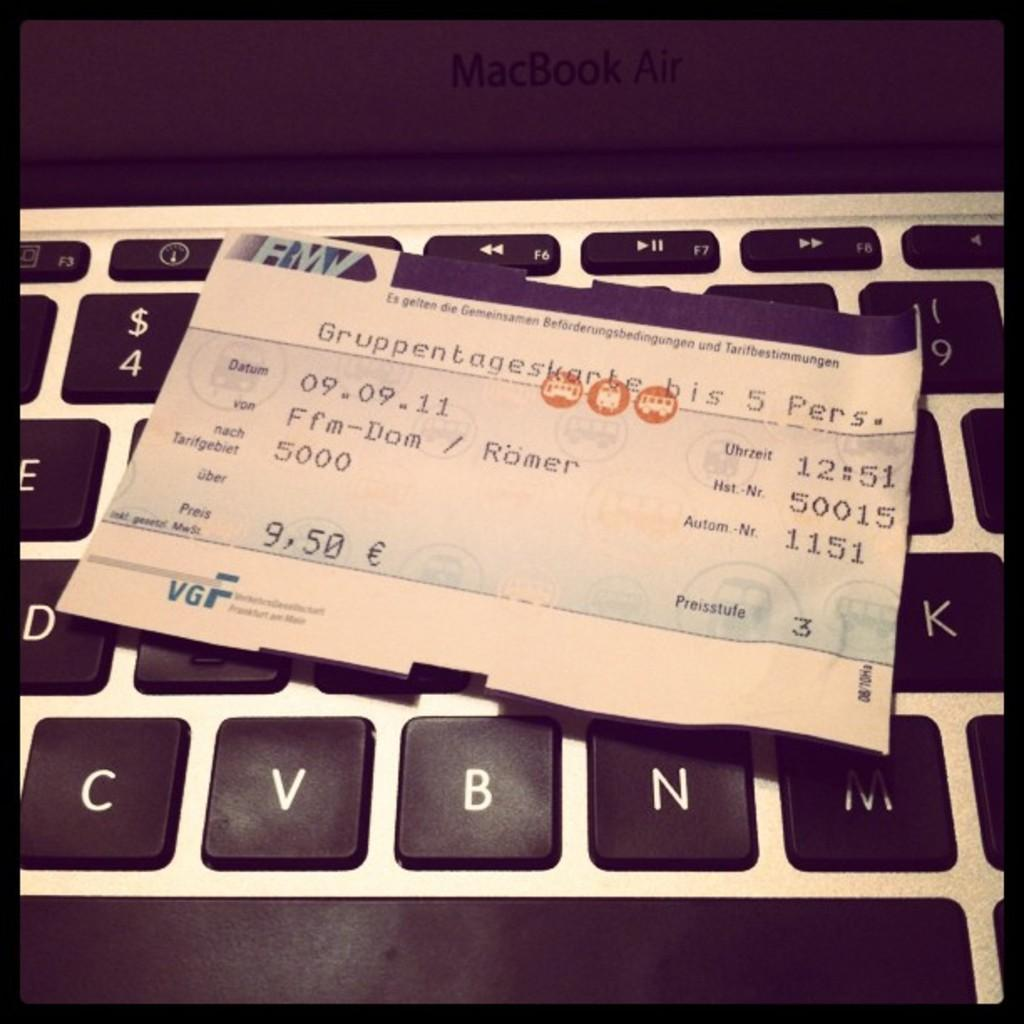<image>
Relay a brief, clear account of the picture shown. A ticket on a keyboard, the ticket having the price 9 euros fifty 